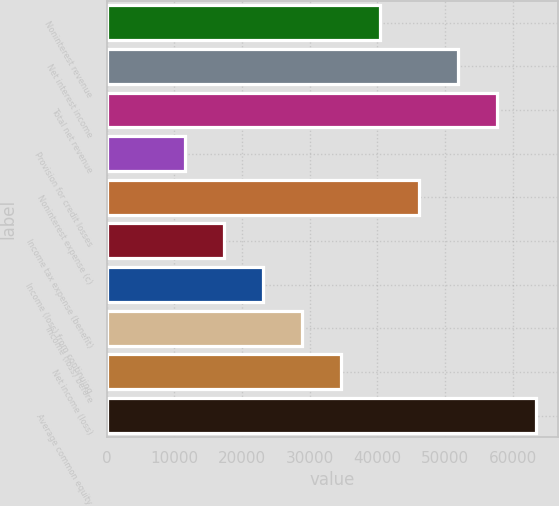Convert chart to OTSL. <chart><loc_0><loc_0><loc_500><loc_500><bar_chart><fcel>Noninterest revenue<fcel>Net interest income<fcel>Total net revenue<fcel>Provision for credit losses<fcel>Noninterest expense (c)<fcel>Income tax expense (benefit)<fcel>Income (loss) from continuing<fcel>Income (loss) before<fcel>Net income (loss)<fcel>Average common equity<nl><fcel>40433.2<fcel>51980.4<fcel>57754<fcel>11565.2<fcel>46206.8<fcel>17338.8<fcel>23112.4<fcel>28886<fcel>34659.6<fcel>63527.6<nl></chart> 